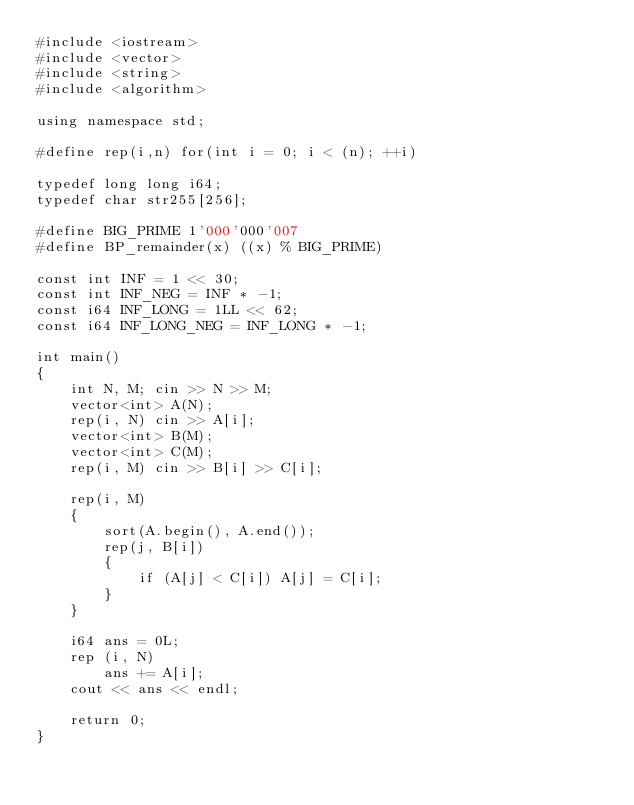<code> <loc_0><loc_0><loc_500><loc_500><_C++_>#include <iostream>
#include <vector>
#include <string>
#include <algorithm>

using namespace std;

#define rep(i,n) for(int i = 0; i < (n); ++i)
 
typedef long long i64;
typedef char str255[256];

#define BIG_PRIME 1'000'000'007
#define BP_remainder(x) ((x) % BIG_PRIME)

const int INF = 1 << 30;
const int INF_NEG = INF * -1;
const i64 INF_LONG = 1LL << 62;
const i64 INF_LONG_NEG = INF_LONG * -1;

int main()
{
    int N, M; cin >> N >> M;
    vector<int> A(N);
    rep(i, N) cin >> A[i];
    vector<int> B(M);
    vector<int> C(M);
    rep(i, M) cin >> B[i] >> C[i];

    rep(i, M)
    {
        sort(A.begin(), A.end());
        rep(j, B[i])
        {
            if (A[j] < C[i]) A[j] = C[i];
        }
    }

    i64 ans = 0L;
    rep (i, N)
        ans += A[i];
    cout << ans << endl;

    return 0;
}
</code> 